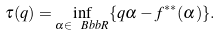Convert formula to latex. <formula><loc_0><loc_0><loc_500><loc_500>\tau ( q ) = \inf _ { \alpha \in \ B b b { R } } \{ q \alpha - f ^ { * * } ( \alpha ) \} .</formula> 